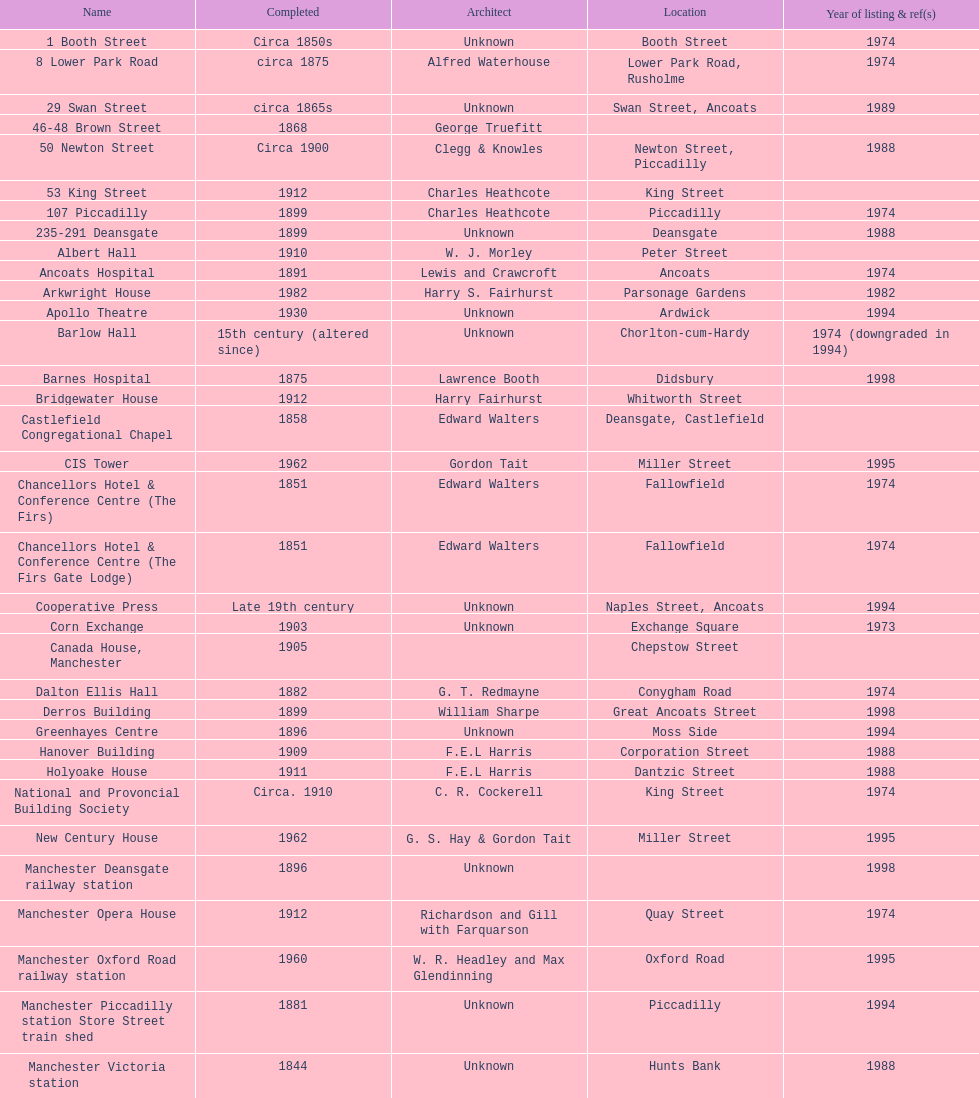Would you mind parsing the complete table? {'header': ['Name', 'Completed', 'Architect', 'Location', 'Year of listing & ref(s)'], 'rows': [['1 Booth Street', 'Circa 1850s', 'Unknown', 'Booth Street', '1974'], ['8 Lower Park Road', 'circa 1875', 'Alfred Waterhouse', 'Lower Park Road, Rusholme', '1974'], ['29 Swan Street', 'circa 1865s', 'Unknown', 'Swan Street, Ancoats', '1989'], ['46-48 Brown Street', '1868', 'George Truefitt', '', ''], ['50 Newton Street', 'Circa 1900', 'Clegg & Knowles', 'Newton Street, Piccadilly', '1988'], ['53 King Street', '1912', 'Charles Heathcote', 'King Street', ''], ['107 Piccadilly', '1899', 'Charles Heathcote', 'Piccadilly', '1974'], ['235-291 Deansgate', '1899', 'Unknown', 'Deansgate', '1988'], ['Albert Hall', '1910', 'W. J. Morley', 'Peter Street', ''], ['Ancoats Hospital', '1891', 'Lewis and Crawcroft', 'Ancoats', '1974'], ['Arkwright House', '1982', 'Harry S. Fairhurst', 'Parsonage Gardens', '1982'], ['Apollo Theatre', '1930', 'Unknown', 'Ardwick', '1994'], ['Barlow Hall', '15th century (altered since)', 'Unknown', 'Chorlton-cum-Hardy', '1974 (downgraded in 1994)'], ['Barnes Hospital', '1875', 'Lawrence Booth', 'Didsbury', '1998'], ['Bridgewater House', '1912', 'Harry Fairhurst', 'Whitworth Street', ''], ['Castlefield Congregational Chapel', '1858', 'Edward Walters', 'Deansgate, Castlefield', ''], ['CIS Tower', '1962', 'Gordon Tait', 'Miller Street', '1995'], ['Chancellors Hotel & Conference Centre (The Firs)', '1851', 'Edward Walters', 'Fallowfield', '1974'], ['Chancellors Hotel & Conference Centre (The Firs Gate Lodge)', '1851', 'Edward Walters', 'Fallowfield', '1974'], ['Cooperative Press', 'Late 19th century', 'Unknown', 'Naples Street, Ancoats', '1994'], ['Corn Exchange', '1903', 'Unknown', 'Exchange Square', '1973'], ['Canada House, Manchester', '1905', '', 'Chepstow Street', ''], ['Dalton Ellis Hall', '1882', 'G. T. Redmayne', 'Conygham Road', '1974'], ['Derros Building', '1899', 'William Sharpe', 'Great Ancoats Street', '1998'], ['Greenhayes Centre', '1896', 'Unknown', 'Moss Side', '1994'], ['Hanover Building', '1909', 'F.E.L Harris', 'Corporation Street', '1988'], ['Holyoake House', '1911', 'F.E.L Harris', 'Dantzic Street', '1988'], ['National and Provoncial Building Society', 'Circa. 1910', 'C. R. Cockerell', 'King Street', '1974'], ['New Century House', '1962', 'G. S. Hay & Gordon Tait', 'Miller Street', '1995'], ['Manchester Deansgate railway station', '1896', 'Unknown', '', '1998'], ['Manchester Opera House', '1912', 'Richardson and Gill with Farquarson', 'Quay Street', '1974'], ['Manchester Oxford Road railway station', '1960', 'W. R. Headley and Max Glendinning', 'Oxford Road', '1995'], ['Manchester Piccadilly station Store Street train shed', '1881', 'Unknown', 'Piccadilly', '1994'], ['Manchester Victoria station', '1844', 'Unknown', 'Hunts Bank', '1988'], ['Palace Theatre', '1891', 'Alfred Derbyshire and F.Bennett Smith', 'Oxford Street', '1977'], ['The Ritz', '1927', 'Unknown', 'Whitworth Street', '1994'], ['Royal Exchange', '1921', 'Bradshaw, Gass & Hope', 'Cross Street', ''], ['Redfern Building', '1936', 'W. A. Johnson and J. W. Cooper', 'Dantzic Street', '1994'], ['Sackville Street Building', '1912', 'Spalding and Cross', 'Sackville Street', '1974'], ['St. James Buildings', '1912', 'Clegg, Fryer & Penman', '65-95 Oxford Street', '1988'], ["St Mary's Hospital", '1909', 'John Ely', 'Wilmslow Road', '1994'], ['Samuel Alexander Building', '1919', 'Percy Scott Worthington', 'Oxford Road', '2010'], ['Ship Canal House', '1927', 'Harry S. Fairhurst', 'King Street', '1982'], ['Smithfield Market Hall', '1857', 'Unknown', 'Swan Street, Ancoats', '1973'], ['Strangeways Gaol Gatehouse', '1868', 'Alfred Waterhouse', 'Sherborne Street', '1974'], ['Strangeways Prison ventilation and watch tower', '1868', 'Alfred Waterhouse', 'Sherborne Street', '1974'], ['Theatre Royal', '1845', 'Irwin and Chester', 'Peter Street', '1974'], ['Toast Rack', '1960', 'L. C. Howitt', 'Fallowfield', '1999'], ['The Old Wellington Inn', 'Mid-16th century', 'Unknown', 'Shambles Square', '1952'], ['Whitworth Park Mansions', 'Circa 1840s', 'Unknown', 'Whitworth Park', '1974']]} How many names are listed with an image? 39. 